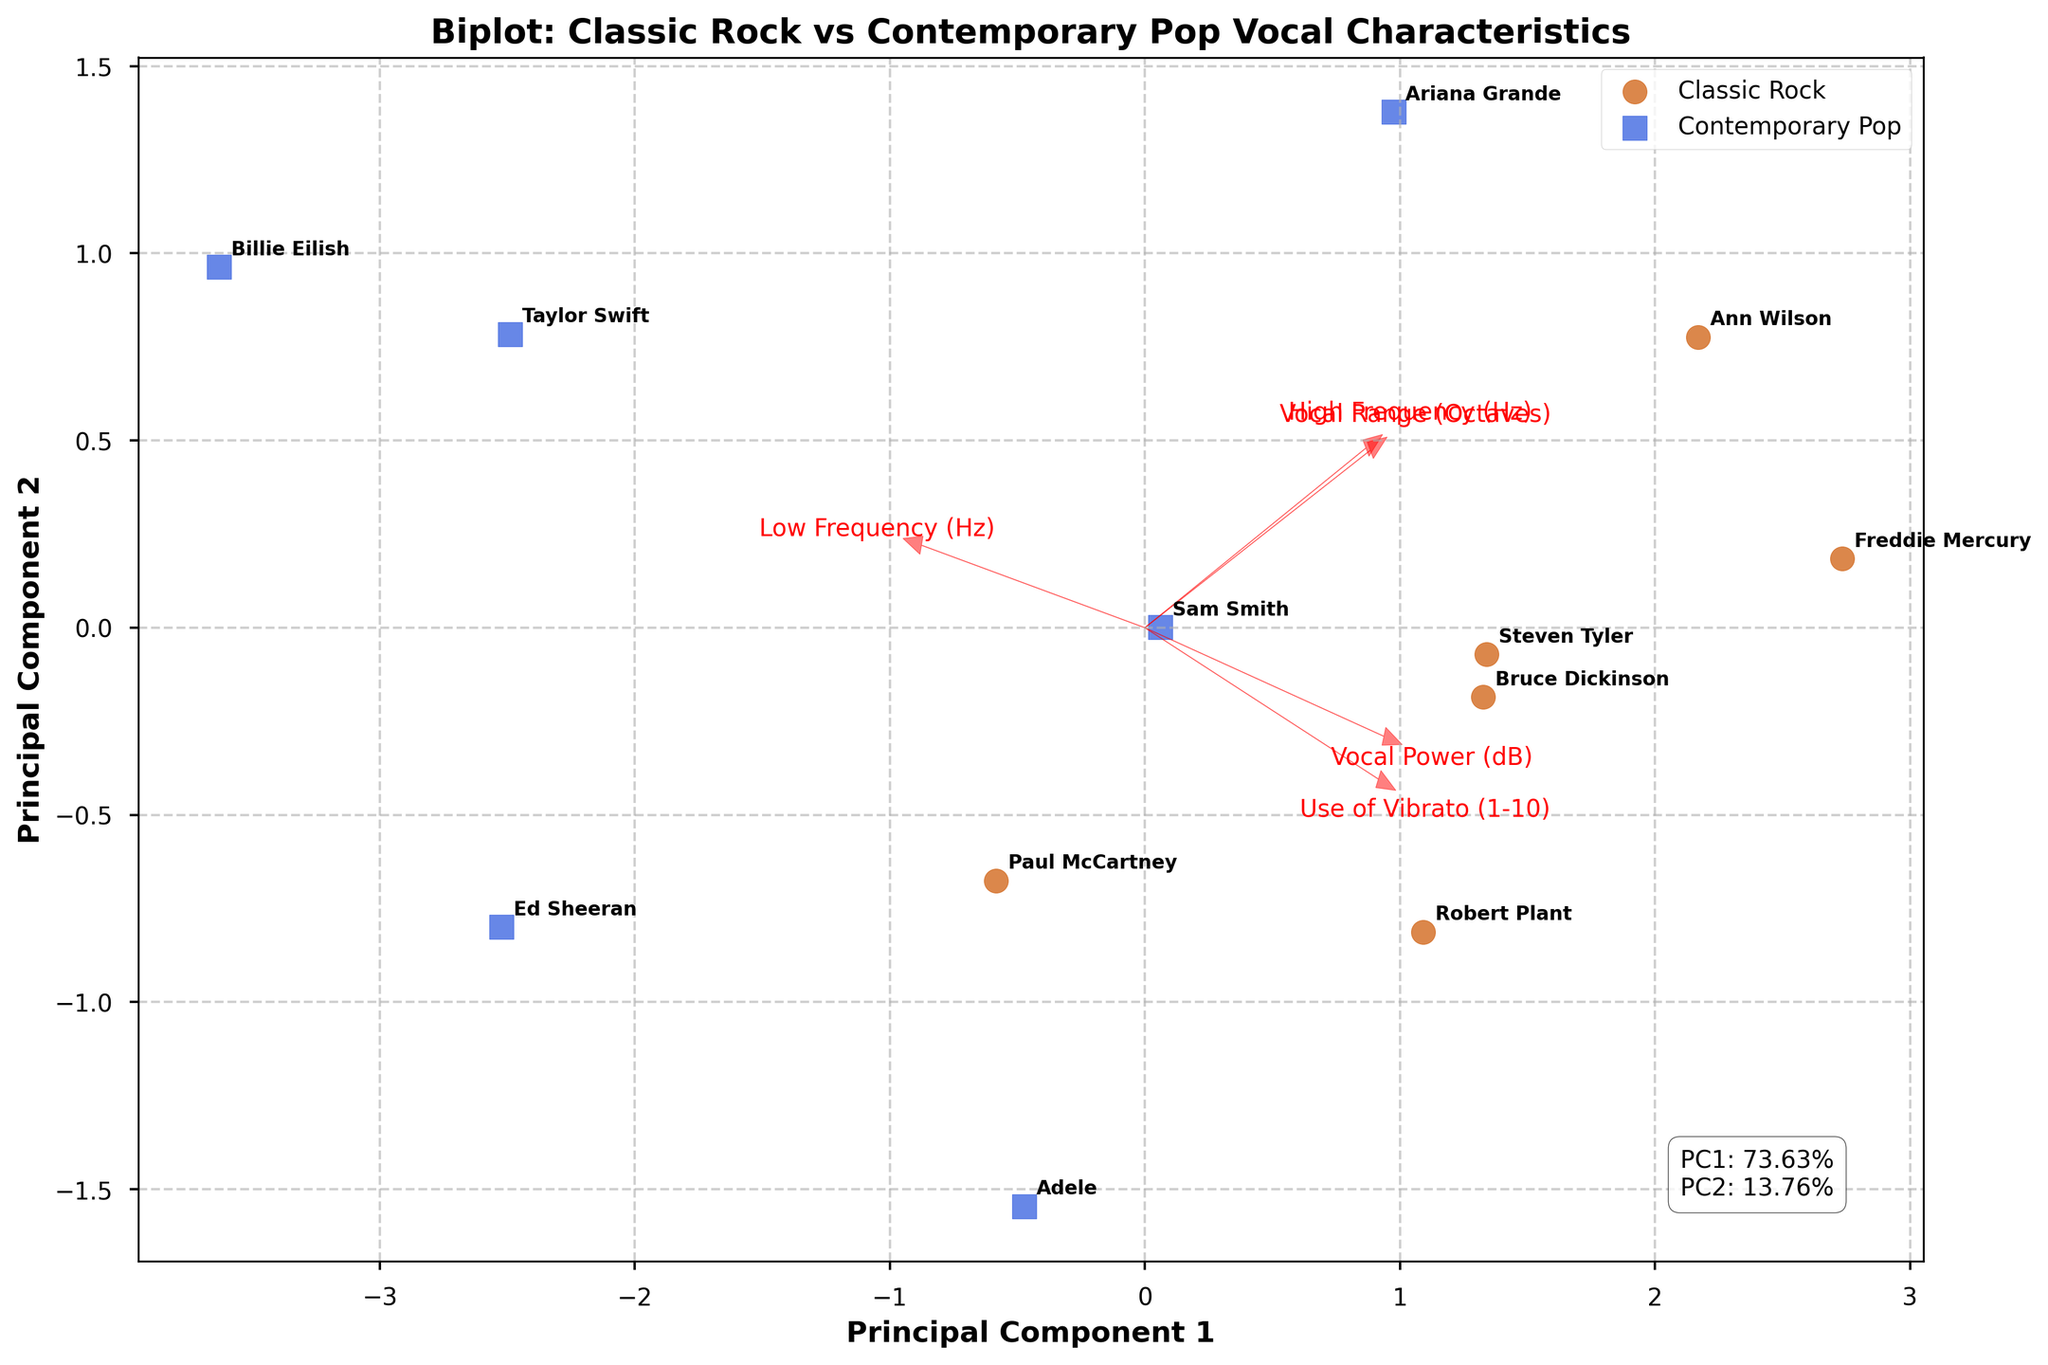What's the title of the figure? The title is usually found at the top of the figure, which should be explicitly named. Reading directly from that portion gives us the answer.
Answer: Biplot: Classic Rock vs Contemporary Pop Vocal Characteristics How many classic rock singers are represented in the plot? Classic rock singers can be identified by the specific marker and color assigned to them. Counting the instances of that marker gives their total number.
Answer: 6 Which two vocal characteristics are best represented by the principal components in this plot? The axes of the biplot represent the principal components, and the feature loadings (arrows) indicate the strength of each characteristic on these components. Observing the length and direction of the arrows helps determine the most represented characteristics.
Answer: Vocal Range (Octaves) and Use of Vibrato (1-10) Which singer has the highest vocal power and from which genre are they? The position of the singer in the plot can be correlated with the length of the arrow representing vocal power. Checking the markers and annotations can identify which singer this is.
Answer: Freddie Mercury, Classic Rock Are there more classic rock singers with a low-frequency range below 70 Hz compared to contemporary pop singers? By examining the annotations and their respective positions related to the low-frequency loadings, we can count the singers from each genre below 70 Hz.
Answer: Yes 